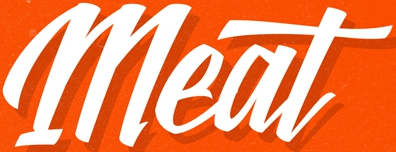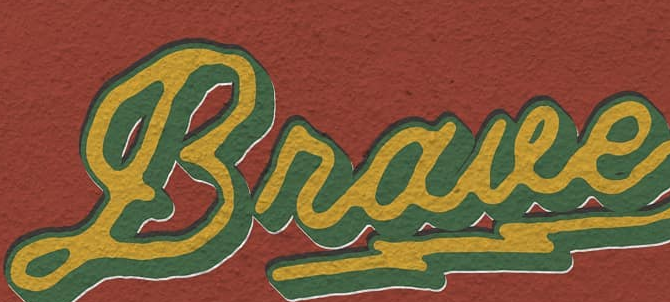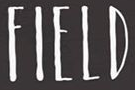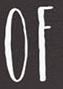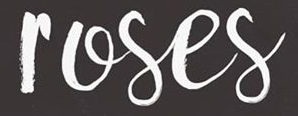Identify the words shown in these images in order, separated by a semicolon. Meat; Braue; FIELD; OF; roses 